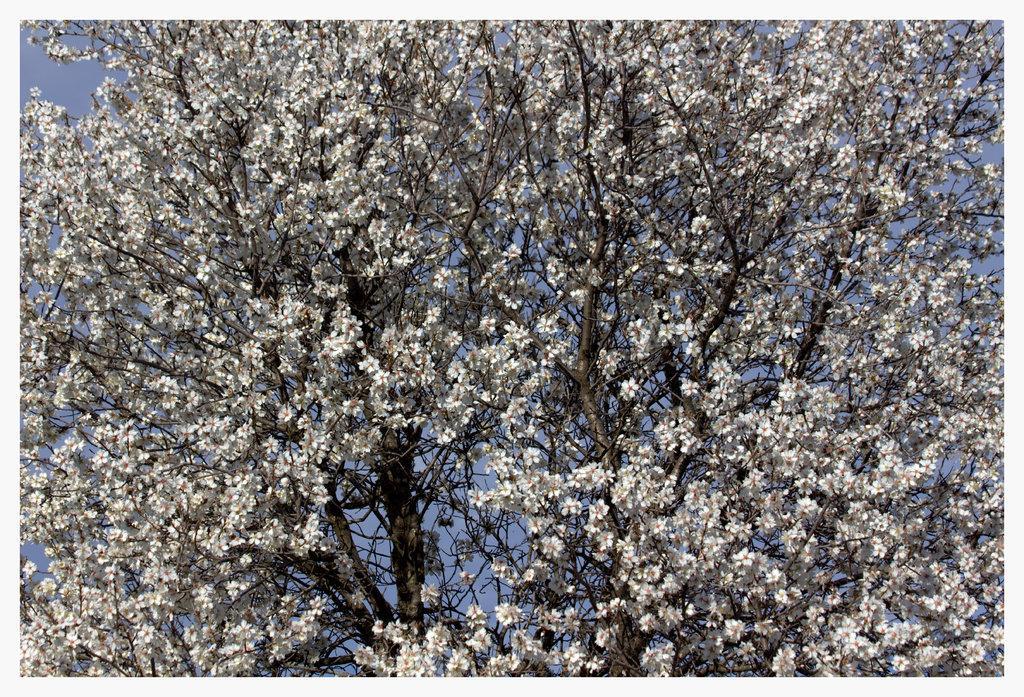In one or two sentences, can you explain what this image depicts? As we can see in the image there are trees, white color flowers and sky. 